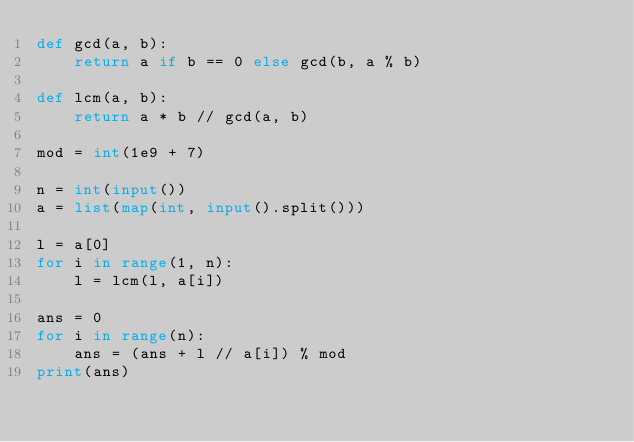<code> <loc_0><loc_0><loc_500><loc_500><_Python_>def gcd(a, b):
    return a if b == 0 else gcd(b, a % b)

def lcm(a, b):
    return a * b // gcd(a, b)

mod = int(1e9 + 7)

n = int(input())
a = list(map(int, input().split()))

l = a[0]
for i in range(1, n):
    l = lcm(l, a[i])

ans = 0
for i in range(n):
    ans = (ans + l // a[i]) % mod
print(ans)</code> 